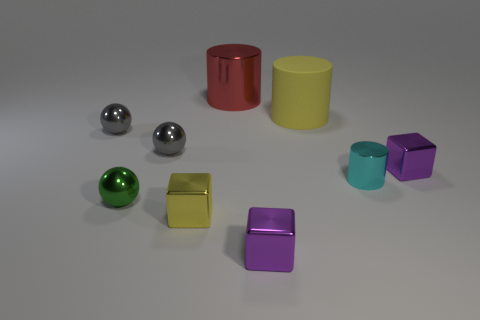What number of metallic objects are balls or small purple blocks?
Offer a terse response. 5. The purple object to the left of the purple object right of the cyan cylinder is what shape?
Provide a succinct answer. Cube. Do the purple cube behind the small cyan cylinder and the purple thing in front of the small cyan cylinder have the same material?
Offer a very short reply. Yes. There is a purple shiny thing that is behind the cyan shiny thing; what number of cylinders are behind it?
Make the answer very short. 2. Does the yellow object that is behind the yellow metal cube have the same shape as the red object to the right of the tiny yellow metal cube?
Provide a short and direct response. Yes. There is a cylinder that is both right of the big red cylinder and to the left of the tiny metallic cylinder; what size is it?
Your answer should be compact. Large. There is a small shiny object that is the same shape as the big yellow object; what color is it?
Provide a short and direct response. Cyan. What is the color of the shiny sphere that is in front of the purple thing behind the tiny yellow metallic cube?
Provide a short and direct response. Green. The tiny cyan thing is what shape?
Offer a terse response. Cylinder. The tiny metal thing that is behind the cyan thing and on the right side of the matte cylinder has what shape?
Provide a short and direct response. Cube. 